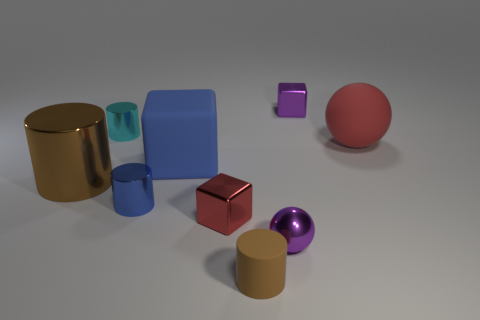Subtract 1 cylinders. How many cylinders are left? 3 Add 1 big shiny objects. How many objects exist? 10 Subtract all spheres. How many objects are left? 7 Add 4 brown objects. How many brown objects exist? 6 Subtract 0 brown spheres. How many objects are left? 9 Subtract all large blue things. Subtract all big blue cubes. How many objects are left? 7 Add 7 large objects. How many large objects are left? 10 